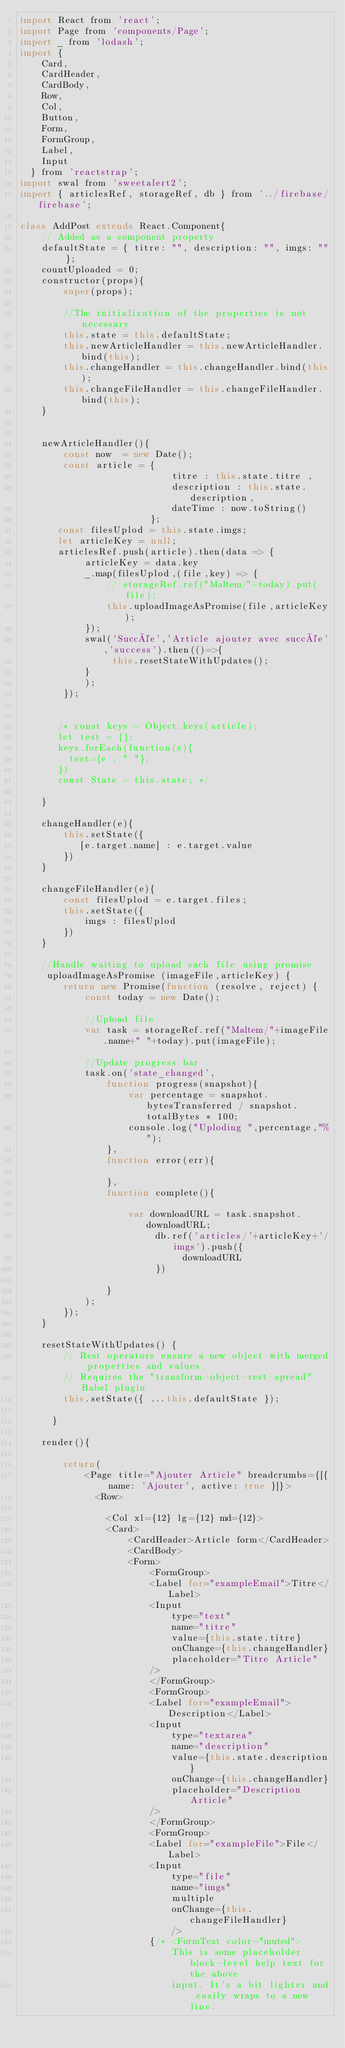Convert code to text. <code><loc_0><loc_0><loc_500><loc_500><_JavaScript_>import React from 'react';
import Page from 'components/Page';
import _ from 'lodash';
import {
    Card,
    CardHeader,
    CardBody,
    Row,
    Col,
    Button,
    Form,
    FormGroup,
    Label,
    Input
  } from 'reactstrap';
import swal from 'sweetalert2';
import { articlesRef, storageRef, db } from '../firebase/firebase';

class AddPost extends React.Component{
    // Added as a component property
    defaultState = { titre: "", description: "", imgs: "" };
    countUploaded = 0;
    constructor(props){
        super(props);
         
        //The initialization of the properties is not necessary
        this.state = this.defaultState;
        this.newArticleHandler = this.newArticleHandler.bind(this);
        this.changeHandler = this.changeHandler.bind(this);
        this.changeFileHandler = this.changeFileHandler.bind(this);  
    }


    newArticleHandler(){
        const now  = new Date();
        const article = {
                            titre : this.state.titre ,
                            description : this.state.description,
                            dateTime : now.toString()
                        };
       const filesUplod = this.state.imgs;
       let articleKey = null;
       articlesRef.push(article).then(data => {
            articleKey = data.key
            _.map(filesUplod,(file,key) => {
                // storageRef.ref("Maltem/"+today).put(file);
                this.uploadImageAsPromise(file,articleKey);  
            });
            swal('Succée','Article ajouter avec succée','success').then(()=>{
                 this.resetStateWithUpdates();
            }
            );
        });

       
       /* const keys = Object.keys(article);
       let test = {};
       keys.forEach(function(e){
         test={e : " "};
       })
       const State = this.state; */
      
    }

    changeHandler(e){
        this.setState({
           [e.target.name] : e.target.value
        })
    }

    changeFileHandler(e){
        const filesUplod = e.target.files;
        this.setState({
            imgs : filesUplod
        })
    }

    //Handle waiting to upload each file using promise
     uploadImageAsPromise (imageFile,articleKey) {
        return new Promise(function (resolve, reject) {
            const today = new Date();
           
            //Upload file
            var task = storageRef.ref("Maltem/"+imageFile.name+" "+today).put(imageFile);
    
            //Update progress bar
            task.on('state_changed',
                function progress(snapshot){
                    var percentage = snapshot.bytesTransferred / snapshot.totalBytes * 100;
                    console.log("Uploding ",percentage,"%");
                },
                function error(err){
    
                },
                function complete(){
              
                    var downloadURL = task.snapshot.downloadURL;
                         db.ref('articles/'+articleKey+'/imgs').push({
                              downloadURL
                         })
                        
                }
            );
        });
    }

    resetStateWithUpdates() {
        // Rest operators ensure a new object with merged properties and values.
        // Requires the "transform-object-rest-spread" Babel plugin
        this.setState({ ...this.defaultState });
        
      }
      
    render(){

        return(
            <Page title="Ajouter Article" breadcrumbs={[{ name: 'Ajouter', active: true }]}>
              <Row>

                <Col xl={12} lg={12} md={12}>
                <Card>
                    <CardHeader>Article form</CardHeader>
                    <CardBody>
                    <Form>
                        <FormGroup>
                        <Label for="exampleEmail">Titre</Label>
                        <Input
                            type="text"
                            name="titre"
                            value={this.state.titre}
                            onChange={this.changeHandler}
                            placeholder="Titre Article"
                        />
                        </FormGroup>
                        <FormGroup>
                        <Label for="exampleEmail">Description</Label>
                        <Input
                            type="textarea"
                            name="description"
                            value={this.state.description}                            
                            onChange={this.changeHandler}
                            placeholder="Description Article"
                        />
                        </FormGroup>
                        <FormGroup>
                        <Label for="exampleFile">File</Label>
                        <Input 
                            type="file" 
                            name="imgs" 
                            multiple
                            onChange={this.changeFileHandler}
                            />
                        {/* <FormText color="muted">
                            This is some placeholder block-level help text for the above
                            input. It's a bit lighter and easily wraps to a new line.</code> 